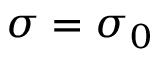<formula> <loc_0><loc_0><loc_500><loc_500>\sigma = \sigma _ { 0 }</formula> 